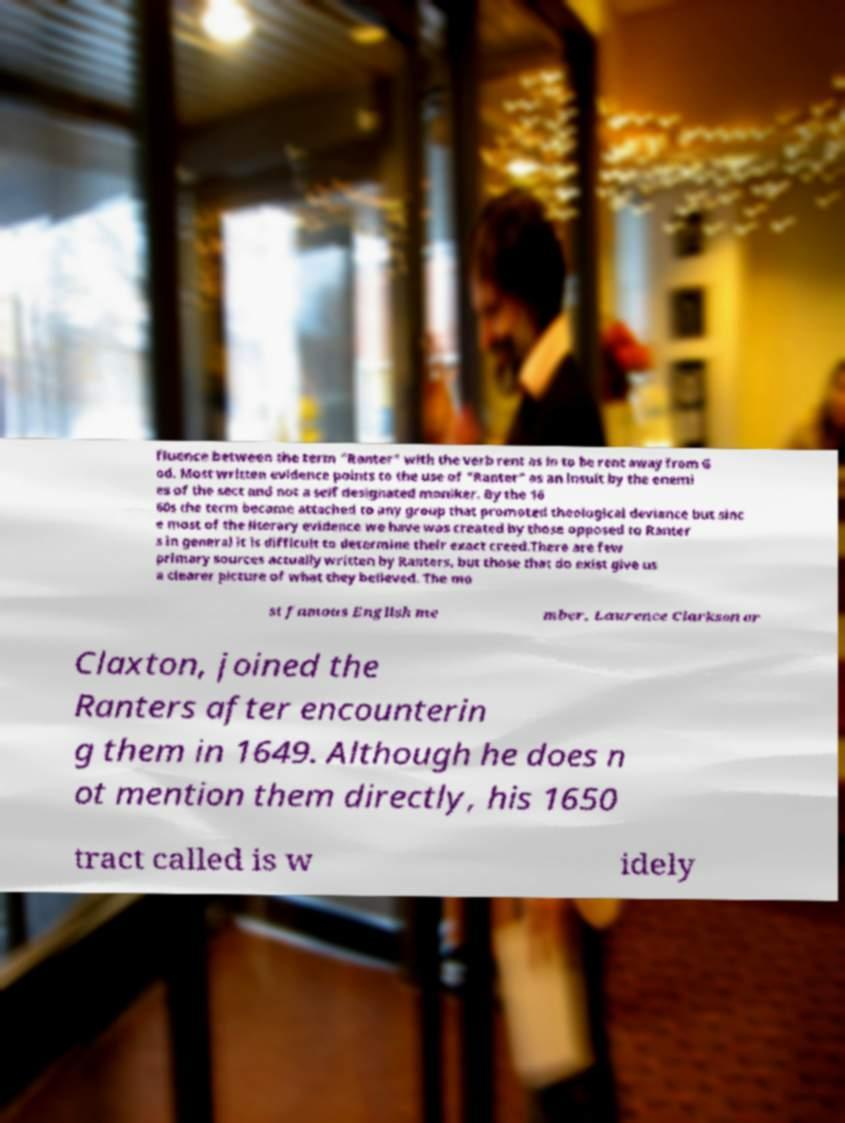For documentation purposes, I need the text within this image transcribed. Could you provide that? fluence between the term "Ranter" with the verb rent as in to be rent away from G od. Most written evidence points to the use of "Ranter" as an insult by the enemi es of the sect and not a self designated moniker. By the 16 60s the term became attached to any group that promoted theological deviance but sinc e most of the literary evidence we have was created by those opposed to Ranter s in general it is difficult to determine their exact creed.There are few primary sources actually written by Ranters, but those that do exist give us a clearer picture of what they believed. The mo st famous English me mber, Laurence Clarkson or Claxton, joined the Ranters after encounterin g them in 1649. Although he does n ot mention them directly, his 1650 tract called is w idely 